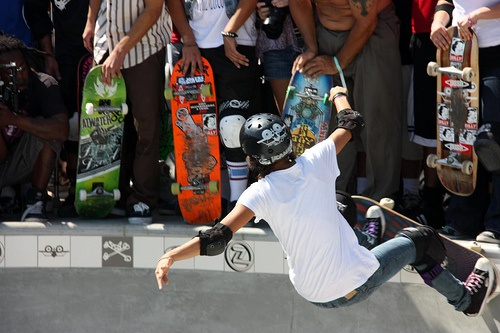Describe the objects in this image and their specific colors. I can see people in navy, lightgray, black, gray, and lavender tones, people in navy, black, maroon, brown, and gray tones, people in navy, black, darkgray, gray, and maroon tones, people in navy, black, and gray tones, and people in navy, black, maroon, and darkgray tones in this image. 